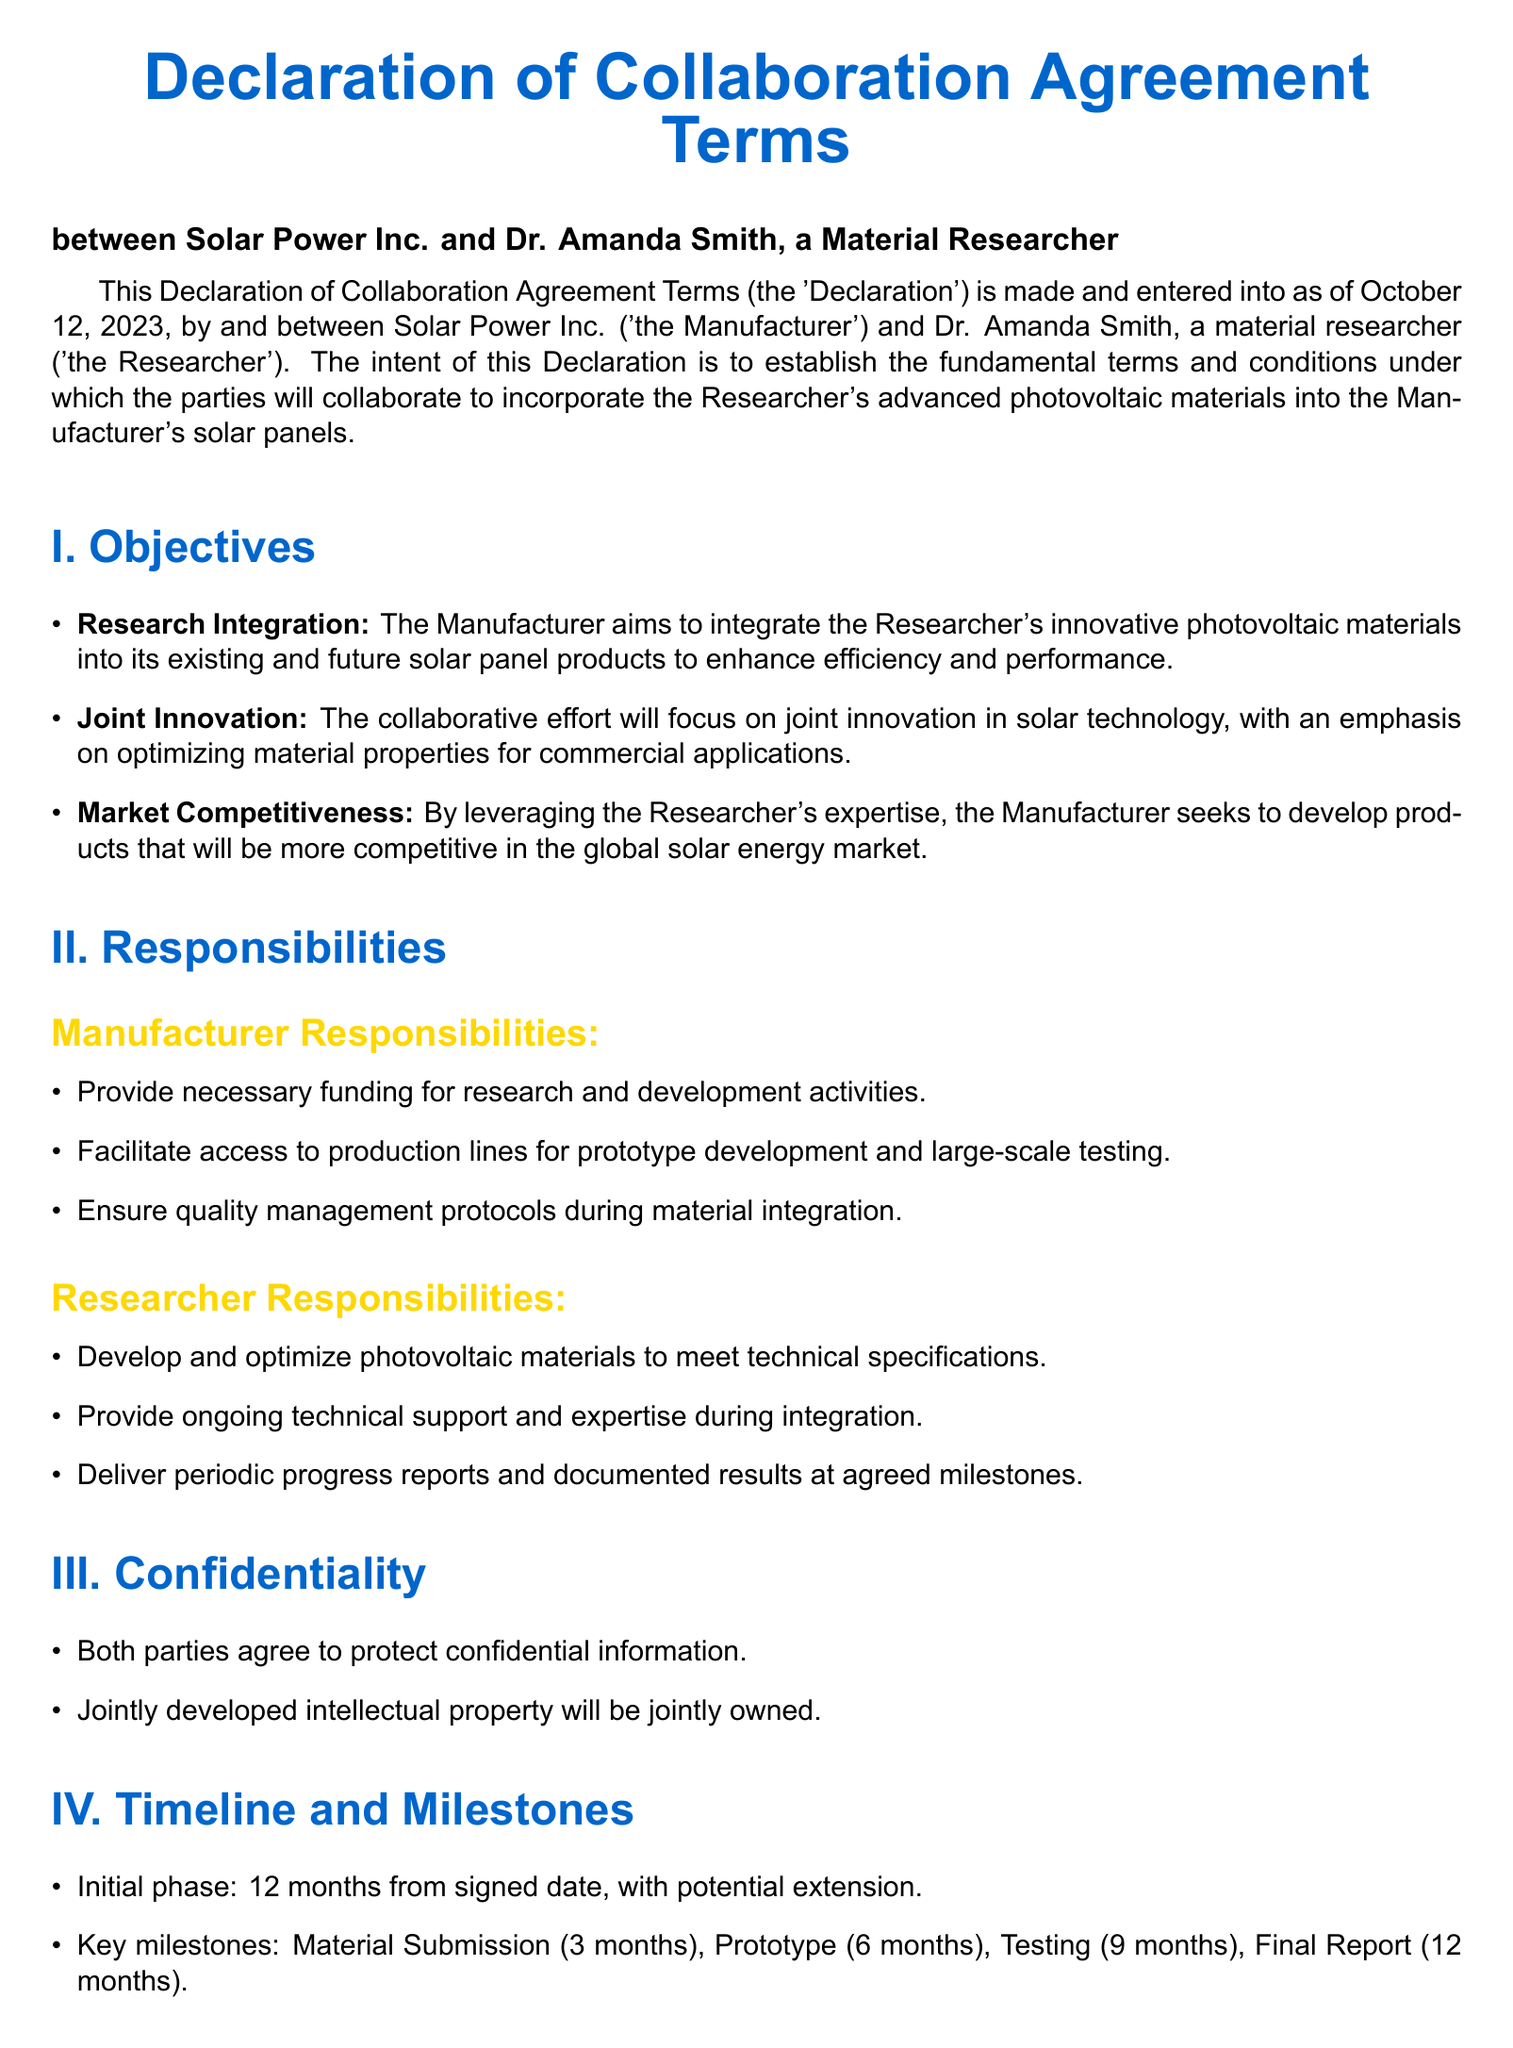What is the name of the Manufacturer? The Manufacturer is referred to as Solar Power Inc. in the document.
Answer: Solar Power Inc What is the name of the Researcher? The Researcher is identified as Dr. Amanda Smith in the Declaration.
Answer: Dr. Amanda Smith When was the Declaration signed? The signing date is mentioned at the beginning of the document.
Answer: October 12, 2023 What is the duration of the initial phase? The initial phase is specified in the Timeline and Milestones section of the document.
Answer: 12 months What milestone is due at 6 months? The key milestones are outlined, including the one due at 6 months.
Answer: Prototype What is the primary objective of the Manufacturer? The objectives of the collaboration describe the Manufacturer's primary aim.
Answer: Research Integration What is the notice period for termination? The termination section specifies the notice period required.
Answer: 60-day How will disputes be resolved? The document states the method for addressing disputes.
Answer: Mediation Who will own the jointly developed intellectual property? The confidentiality section addresses the ownership of jointly developed intellectual property.
Answer: Jointly owned 